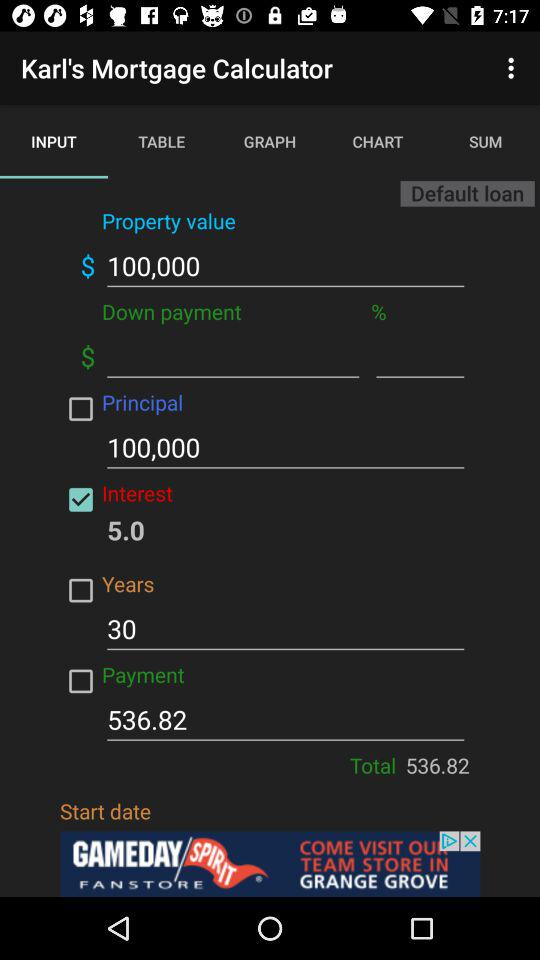How many years will the mortgage last?
Answer the question using a single word or phrase. 30 